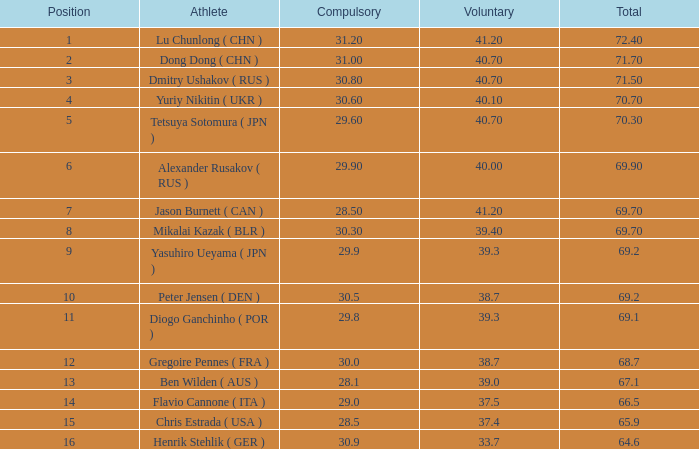2 and the optional is 3 0.0. 